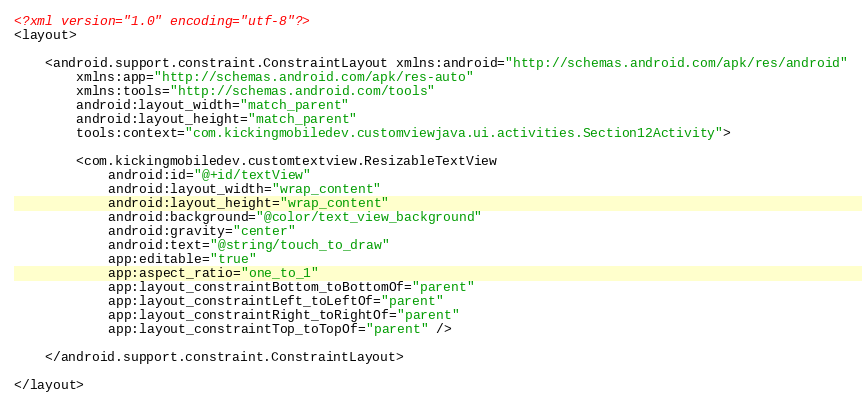Convert code to text. <code><loc_0><loc_0><loc_500><loc_500><_XML_><?xml version="1.0" encoding="utf-8"?>
<layout>

    <android.support.constraint.ConstraintLayout xmlns:android="http://schemas.android.com/apk/res/android"
        xmlns:app="http://schemas.android.com/apk/res-auto"
        xmlns:tools="http://schemas.android.com/tools"
        android:layout_width="match_parent"
        android:layout_height="match_parent"
        tools:context="com.kickingmobiledev.customviewjava.ui.activities.Section12Activity">

        <com.kickingmobiledev.customtextview.ResizableTextView
            android:id="@+id/textView"
            android:layout_width="wrap_content"
            android:layout_height="wrap_content"
            android:background="@color/text_view_background"
            android:gravity="center"
            android:text="@string/touch_to_draw"
            app:editable="true"
            app:aspect_ratio="one_to_1"
            app:layout_constraintBottom_toBottomOf="parent"
            app:layout_constraintLeft_toLeftOf="parent"
            app:layout_constraintRight_toRightOf="parent"
            app:layout_constraintTop_toTopOf="parent" />

    </android.support.constraint.ConstraintLayout>

</layout>
</code> 